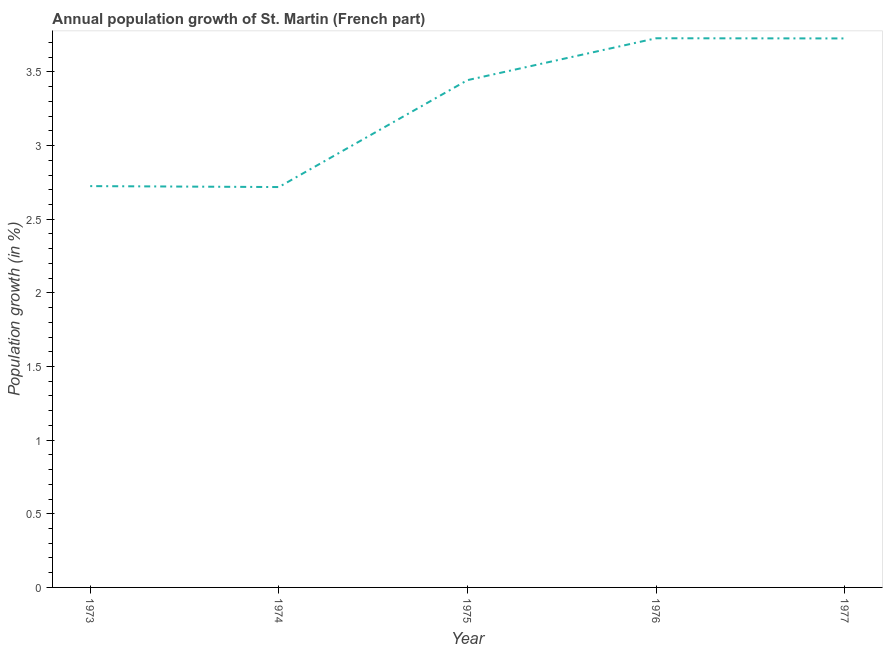What is the population growth in 1976?
Make the answer very short. 3.73. Across all years, what is the maximum population growth?
Ensure brevity in your answer.  3.73. Across all years, what is the minimum population growth?
Your response must be concise. 2.72. In which year was the population growth maximum?
Keep it short and to the point. 1976. In which year was the population growth minimum?
Provide a succinct answer. 1974. What is the sum of the population growth?
Your answer should be compact. 16.34. What is the difference between the population growth in 1975 and 1976?
Provide a short and direct response. -0.28. What is the average population growth per year?
Provide a short and direct response. 3.27. What is the median population growth?
Give a very brief answer. 3.44. In how many years, is the population growth greater than 3.4 %?
Keep it short and to the point. 3. Do a majority of the years between 1975 and 1973 (inclusive) have population growth greater than 2.4 %?
Offer a very short reply. No. What is the ratio of the population growth in 1974 to that in 1976?
Ensure brevity in your answer.  0.73. Is the population growth in 1973 less than that in 1977?
Provide a short and direct response. Yes. Is the difference between the population growth in 1973 and 1977 greater than the difference between any two years?
Give a very brief answer. No. What is the difference between the highest and the second highest population growth?
Your answer should be compact. 0. What is the difference between the highest and the lowest population growth?
Offer a very short reply. 1.01. Does the population growth monotonically increase over the years?
Your answer should be very brief. No. Does the graph contain grids?
Offer a very short reply. No. What is the title of the graph?
Offer a very short reply. Annual population growth of St. Martin (French part). What is the label or title of the Y-axis?
Keep it short and to the point. Population growth (in %). What is the Population growth (in %) of 1973?
Make the answer very short. 2.72. What is the Population growth (in %) in 1974?
Your answer should be compact. 2.72. What is the Population growth (in %) of 1975?
Keep it short and to the point. 3.44. What is the Population growth (in %) in 1976?
Your answer should be compact. 3.73. What is the Population growth (in %) of 1977?
Offer a very short reply. 3.73. What is the difference between the Population growth (in %) in 1973 and 1974?
Ensure brevity in your answer.  0.01. What is the difference between the Population growth (in %) in 1973 and 1975?
Offer a terse response. -0.72. What is the difference between the Population growth (in %) in 1973 and 1976?
Keep it short and to the point. -1. What is the difference between the Population growth (in %) in 1973 and 1977?
Keep it short and to the point. -1. What is the difference between the Population growth (in %) in 1974 and 1975?
Provide a succinct answer. -0.73. What is the difference between the Population growth (in %) in 1974 and 1976?
Your response must be concise. -1.01. What is the difference between the Population growth (in %) in 1974 and 1977?
Make the answer very short. -1.01. What is the difference between the Population growth (in %) in 1975 and 1976?
Keep it short and to the point. -0.28. What is the difference between the Population growth (in %) in 1975 and 1977?
Give a very brief answer. -0.28. What is the difference between the Population growth (in %) in 1976 and 1977?
Ensure brevity in your answer.  0. What is the ratio of the Population growth (in %) in 1973 to that in 1974?
Ensure brevity in your answer.  1. What is the ratio of the Population growth (in %) in 1973 to that in 1975?
Ensure brevity in your answer.  0.79. What is the ratio of the Population growth (in %) in 1973 to that in 1976?
Provide a succinct answer. 0.73. What is the ratio of the Population growth (in %) in 1973 to that in 1977?
Offer a very short reply. 0.73. What is the ratio of the Population growth (in %) in 1974 to that in 1975?
Keep it short and to the point. 0.79. What is the ratio of the Population growth (in %) in 1974 to that in 1976?
Offer a very short reply. 0.73. What is the ratio of the Population growth (in %) in 1974 to that in 1977?
Offer a very short reply. 0.73. What is the ratio of the Population growth (in %) in 1975 to that in 1976?
Offer a terse response. 0.92. What is the ratio of the Population growth (in %) in 1975 to that in 1977?
Ensure brevity in your answer.  0.92. 